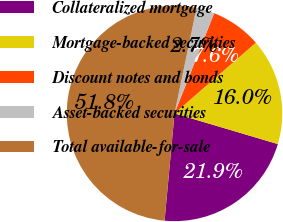Convert chart to OTSL. <chart><loc_0><loc_0><loc_500><loc_500><pie_chart><fcel>Collateralized mortgage<fcel>Mortgage-backed securities<fcel>Discount notes and bonds<fcel>Asset-backed securities<fcel>Total available-for-sale<nl><fcel>21.88%<fcel>15.98%<fcel>7.62%<fcel>2.72%<fcel>51.8%<nl></chart> 